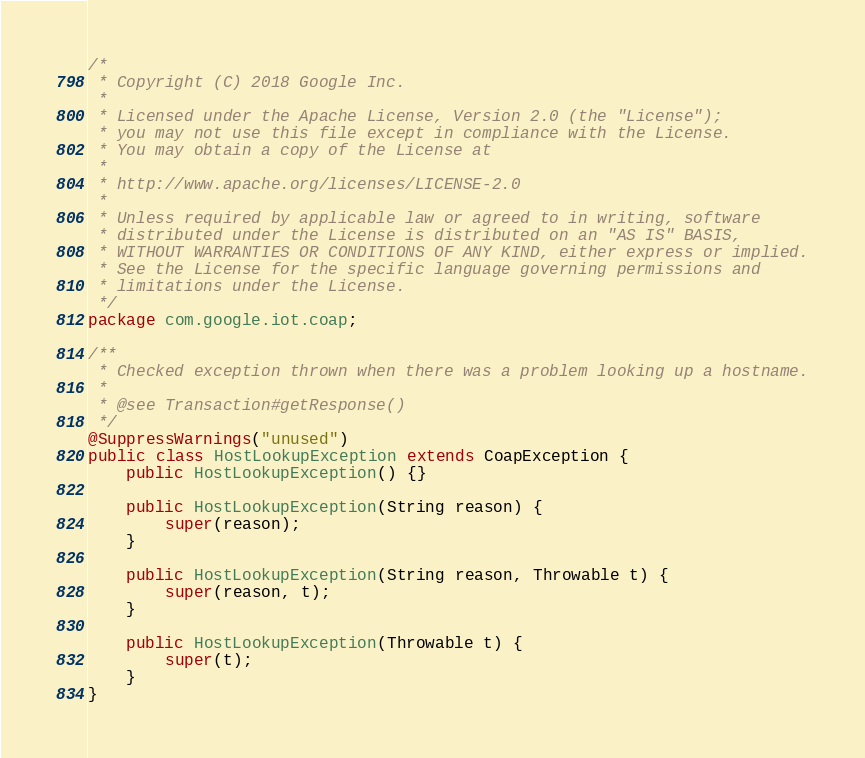Convert code to text. <code><loc_0><loc_0><loc_500><loc_500><_Java_>/*
 * Copyright (C) 2018 Google Inc.
 *
 * Licensed under the Apache License, Version 2.0 (the "License");
 * you may not use this file except in compliance with the License.
 * You may obtain a copy of the License at
 *
 * http://www.apache.org/licenses/LICENSE-2.0
 *
 * Unless required by applicable law or agreed to in writing, software
 * distributed under the License is distributed on an "AS IS" BASIS,
 * WITHOUT WARRANTIES OR CONDITIONS OF ANY KIND, either express or implied.
 * See the License for the specific language governing permissions and
 * limitations under the License.
 */
package com.google.iot.coap;

/**
 * Checked exception thrown when there was a problem looking up a hostname.
 *
 * @see Transaction#getResponse()
 */
@SuppressWarnings("unused")
public class HostLookupException extends CoapException {
    public HostLookupException() {}

    public HostLookupException(String reason) {
        super(reason);
    }

    public HostLookupException(String reason, Throwable t) {
        super(reason, t);
    }

    public HostLookupException(Throwable t) {
        super(t);
    }
}
</code> 